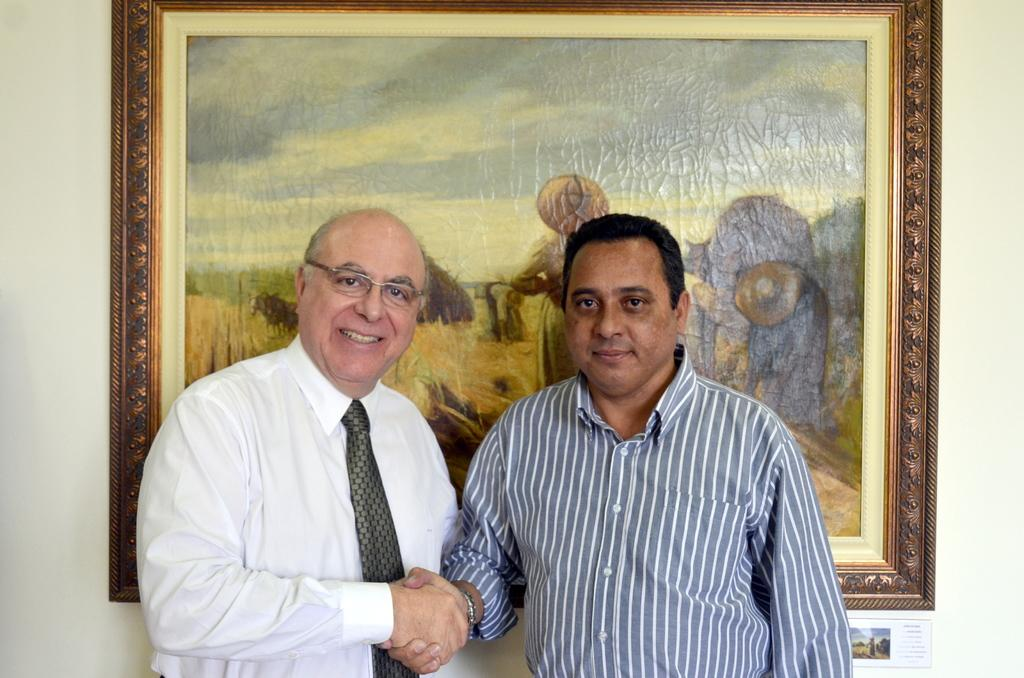How many people are in the image? There are two persons in the image. What are the two persons doing? The two persons are standing and shaking hands. Can you describe anything in the background of the image? There is a photo frame hanging on the wall in the background. Are the two persons in the image sisters? There is no information in the image to suggest that the two persons are sisters. Can you see any fish in the image? There are no fish present in the image. 